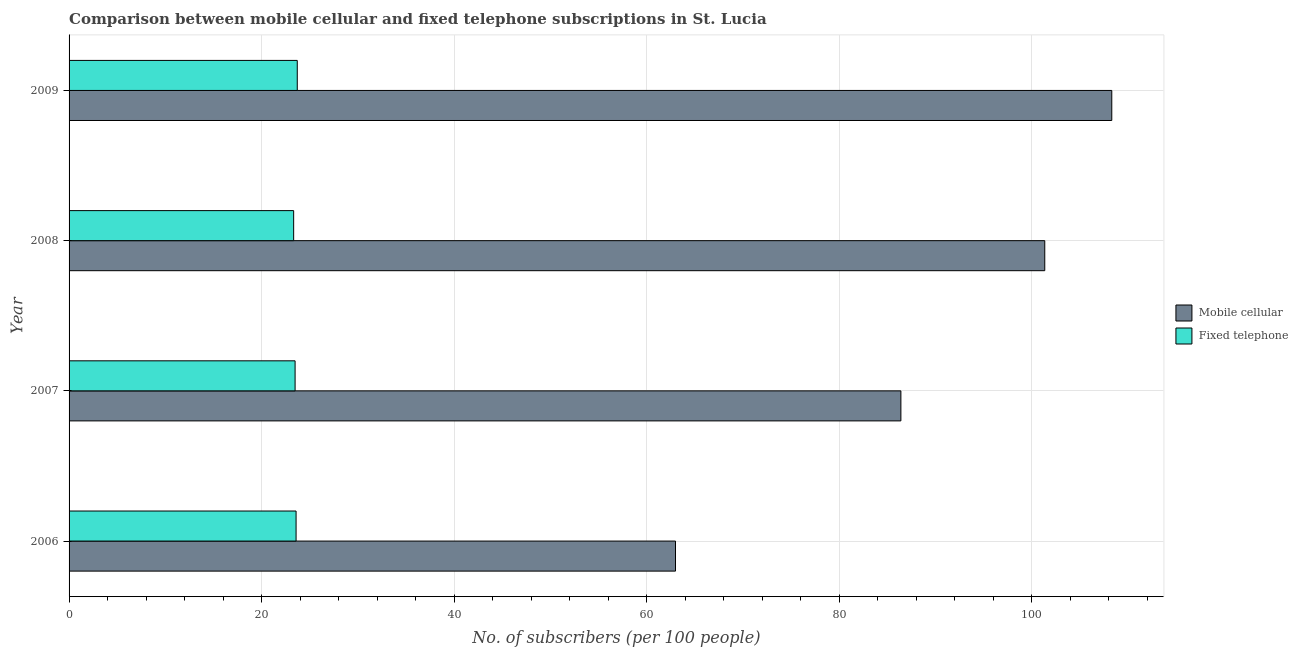How many groups of bars are there?
Your response must be concise. 4. Are the number of bars per tick equal to the number of legend labels?
Make the answer very short. Yes. Are the number of bars on each tick of the Y-axis equal?
Your answer should be compact. Yes. How many bars are there on the 3rd tick from the bottom?
Keep it short and to the point. 2. What is the label of the 1st group of bars from the top?
Provide a short and direct response. 2009. In how many cases, is the number of bars for a given year not equal to the number of legend labels?
Make the answer very short. 0. What is the number of mobile cellular subscribers in 2008?
Ensure brevity in your answer.  101.34. Across all years, what is the maximum number of fixed telephone subscribers?
Keep it short and to the point. 23.7. Across all years, what is the minimum number of fixed telephone subscribers?
Make the answer very short. 23.33. In which year was the number of fixed telephone subscribers maximum?
Ensure brevity in your answer.  2009. In which year was the number of mobile cellular subscribers minimum?
Ensure brevity in your answer.  2006. What is the total number of fixed telephone subscribers in the graph?
Ensure brevity in your answer.  94.08. What is the difference between the number of fixed telephone subscribers in 2006 and that in 2007?
Make the answer very short. 0.1. What is the difference between the number of mobile cellular subscribers in 2008 and the number of fixed telephone subscribers in 2007?
Make the answer very short. 77.86. What is the average number of fixed telephone subscribers per year?
Ensure brevity in your answer.  23.52. In the year 2009, what is the difference between the number of mobile cellular subscribers and number of fixed telephone subscribers?
Make the answer very short. 84.6. In how many years, is the number of fixed telephone subscribers greater than 12 ?
Provide a short and direct response. 4. Is the difference between the number of mobile cellular subscribers in 2007 and 2009 greater than the difference between the number of fixed telephone subscribers in 2007 and 2009?
Your response must be concise. No. What is the difference between the highest and the second highest number of mobile cellular subscribers?
Your response must be concise. 6.96. What is the difference between the highest and the lowest number of mobile cellular subscribers?
Offer a terse response. 45.31. Is the sum of the number of mobile cellular subscribers in 2008 and 2009 greater than the maximum number of fixed telephone subscribers across all years?
Provide a short and direct response. Yes. What does the 2nd bar from the top in 2007 represents?
Offer a very short reply. Mobile cellular. What does the 1st bar from the bottom in 2007 represents?
Your response must be concise. Mobile cellular. Are all the bars in the graph horizontal?
Offer a terse response. Yes. How many years are there in the graph?
Keep it short and to the point. 4. What is the difference between two consecutive major ticks on the X-axis?
Keep it short and to the point. 20. Does the graph contain grids?
Give a very brief answer. Yes. How many legend labels are there?
Make the answer very short. 2. How are the legend labels stacked?
Provide a short and direct response. Vertical. What is the title of the graph?
Keep it short and to the point. Comparison between mobile cellular and fixed telephone subscriptions in St. Lucia. What is the label or title of the X-axis?
Ensure brevity in your answer.  No. of subscribers (per 100 people). What is the No. of subscribers (per 100 people) in Mobile cellular in 2006?
Ensure brevity in your answer.  62.99. What is the No. of subscribers (per 100 people) in Fixed telephone in 2006?
Your answer should be compact. 23.58. What is the No. of subscribers (per 100 people) in Mobile cellular in 2007?
Your response must be concise. 86.39. What is the No. of subscribers (per 100 people) of Fixed telephone in 2007?
Ensure brevity in your answer.  23.47. What is the No. of subscribers (per 100 people) of Mobile cellular in 2008?
Your response must be concise. 101.34. What is the No. of subscribers (per 100 people) of Fixed telephone in 2008?
Provide a short and direct response. 23.33. What is the No. of subscribers (per 100 people) of Mobile cellular in 2009?
Give a very brief answer. 108.3. What is the No. of subscribers (per 100 people) in Fixed telephone in 2009?
Keep it short and to the point. 23.7. Across all years, what is the maximum No. of subscribers (per 100 people) of Mobile cellular?
Keep it short and to the point. 108.3. Across all years, what is the maximum No. of subscribers (per 100 people) of Fixed telephone?
Provide a succinct answer. 23.7. Across all years, what is the minimum No. of subscribers (per 100 people) in Mobile cellular?
Offer a terse response. 62.99. Across all years, what is the minimum No. of subscribers (per 100 people) of Fixed telephone?
Ensure brevity in your answer.  23.33. What is the total No. of subscribers (per 100 people) in Mobile cellular in the graph?
Offer a terse response. 359.02. What is the total No. of subscribers (per 100 people) of Fixed telephone in the graph?
Offer a very short reply. 94.08. What is the difference between the No. of subscribers (per 100 people) of Mobile cellular in 2006 and that in 2007?
Give a very brief answer. -23.41. What is the difference between the No. of subscribers (per 100 people) of Fixed telephone in 2006 and that in 2007?
Offer a terse response. 0.1. What is the difference between the No. of subscribers (per 100 people) of Mobile cellular in 2006 and that in 2008?
Make the answer very short. -38.35. What is the difference between the No. of subscribers (per 100 people) in Fixed telephone in 2006 and that in 2008?
Keep it short and to the point. 0.25. What is the difference between the No. of subscribers (per 100 people) in Mobile cellular in 2006 and that in 2009?
Offer a terse response. -45.31. What is the difference between the No. of subscribers (per 100 people) of Fixed telephone in 2006 and that in 2009?
Ensure brevity in your answer.  -0.12. What is the difference between the No. of subscribers (per 100 people) of Mobile cellular in 2007 and that in 2008?
Offer a very short reply. -14.94. What is the difference between the No. of subscribers (per 100 people) of Fixed telephone in 2007 and that in 2008?
Make the answer very short. 0.15. What is the difference between the No. of subscribers (per 100 people) in Mobile cellular in 2007 and that in 2009?
Provide a short and direct response. -21.9. What is the difference between the No. of subscribers (per 100 people) in Fixed telephone in 2007 and that in 2009?
Your answer should be very brief. -0.23. What is the difference between the No. of subscribers (per 100 people) in Mobile cellular in 2008 and that in 2009?
Provide a succinct answer. -6.96. What is the difference between the No. of subscribers (per 100 people) in Fixed telephone in 2008 and that in 2009?
Provide a short and direct response. -0.38. What is the difference between the No. of subscribers (per 100 people) of Mobile cellular in 2006 and the No. of subscribers (per 100 people) of Fixed telephone in 2007?
Your answer should be compact. 39.51. What is the difference between the No. of subscribers (per 100 people) of Mobile cellular in 2006 and the No. of subscribers (per 100 people) of Fixed telephone in 2008?
Provide a succinct answer. 39.66. What is the difference between the No. of subscribers (per 100 people) in Mobile cellular in 2006 and the No. of subscribers (per 100 people) in Fixed telephone in 2009?
Make the answer very short. 39.28. What is the difference between the No. of subscribers (per 100 people) of Mobile cellular in 2007 and the No. of subscribers (per 100 people) of Fixed telephone in 2008?
Provide a short and direct response. 63.07. What is the difference between the No. of subscribers (per 100 people) of Mobile cellular in 2007 and the No. of subscribers (per 100 people) of Fixed telephone in 2009?
Offer a terse response. 62.69. What is the difference between the No. of subscribers (per 100 people) in Mobile cellular in 2008 and the No. of subscribers (per 100 people) in Fixed telephone in 2009?
Keep it short and to the point. 77.64. What is the average No. of subscribers (per 100 people) in Mobile cellular per year?
Provide a succinct answer. 89.75. What is the average No. of subscribers (per 100 people) of Fixed telephone per year?
Give a very brief answer. 23.52. In the year 2006, what is the difference between the No. of subscribers (per 100 people) in Mobile cellular and No. of subscribers (per 100 people) in Fixed telephone?
Offer a terse response. 39.41. In the year 2007, what is the difference between the No. of subscribers (per 100 people) in Mobile cellular and No. of subscribers (per 100 people) in Fixed telephone?
Provide a succinct answer. 62.92. In the year 2008, what is the difference between the No. of subscribers (per 100 people) of Mobile cellular and No. of subscribers (per 100 people) of Fixed telephone?
Your answer should be very brief. 78.01. In the year 2009, what is the difference between the No. of subscribers (per 100 people) of Mobile cellular and No. of subscribers (per 100 people) of Fixed telephone?
Offer a terse response. 84.6. What is the ratio of the No. of subscribers (per 100 people) of Mobile cellular in 2006 to that in 2007?
Offer a terse response. 0.73. What is the ratio of the No. of subscribers (per 100 people) in Fixed telephone in 2006 to that in 2007?
Ensure brevity in your answer.  1. What is the ratio of the No. of subscribers (per 100 people) of Mobile cellular in 2006 to that in 2008?
Offer a very short reply. 0.62. What is the ratio of the No. of subscribers (per 100 people) of Fixed telephone in 2006 to that in 2008?
Provide a succinct answer. 1.01. What is the ratio of the No. of subscribers (per 100 people) of Mobile cellular in 2006 to that in 2009?
Provide a succinct answer. 0.58. What is the ratio of the No. of subscribers (per 100 people) in Mobile cellular in 2007 to that in 2008?
Make the answer very short. 0.85. What is the ratio of the No. of subscribers (per 100 people) in Fixed telephone in 2007 to that in 2008?
Keep it short and to the point. 1.01. What is the ratio of the No. of subscribers (per 100 people) in Mobile cellular in 2007 to that in 2009?
Give a very brief answer. 0.8. What is the ratio of the No. of subscribers (per 100 people) in Fixed telephone in 2007 to that in 2009?
Your answer should be very brief. 0.99. What is the ratio of the No. of subscribers (per 100 people) in Mobile cellular in 2008 to that in 2009?
Keep it short and to the point. 0.94. What is the ratio of the No. of subscribers (per 100 people) in Fixed telephone in 2008 to that in 2009?
Ensure brevity in your answer.  0.98. What is the difference between the highest and the second highest No. of subscribers (per 100 people) in Mobile cellular?
Your answer should be very brief. 6.96. What is the difference between the highest and the second highest No. of subscribers (per 100 people) in Fixed telephone?
Your answer should be very brief. 0.12. What is the difference between the highest and the lowest No. of subscribers (per 100 people) in Mobile cellular?
Ensure brevity in your answer.  45.31. What is the difference between the highest and the lowest No. of subscribers (per 100 people) in Fixed telephone?
Ensure brevity in your answer.  0.38. 